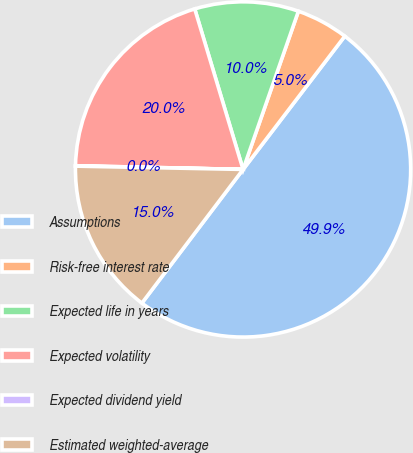Convert chart. <chart><loc_0><loc_0><loc_500><loc_500><pie_chart><fcel>Assumptions<fcel>Risk-free interest rate<fcel>Expected life in years<fcel>Expected volatility<fcel>Expected dividend yield<fcel>Estimated weighted-average<nl><fcel>49.93%<fcel>5.02%<fcel>10.01%<fcel>19.99%<fcel>0.04%<fcel>15.0%<nl></chart> 